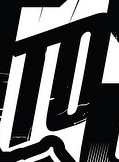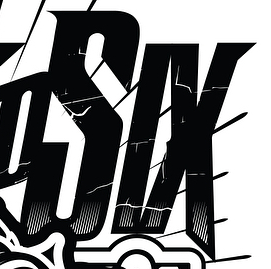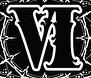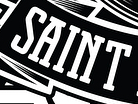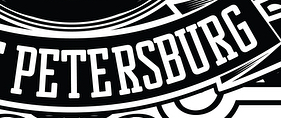Transcribe the words shown in these images in order, separated by a semicolon. TO; SIX; VI; SAINT; PETERSBURG 